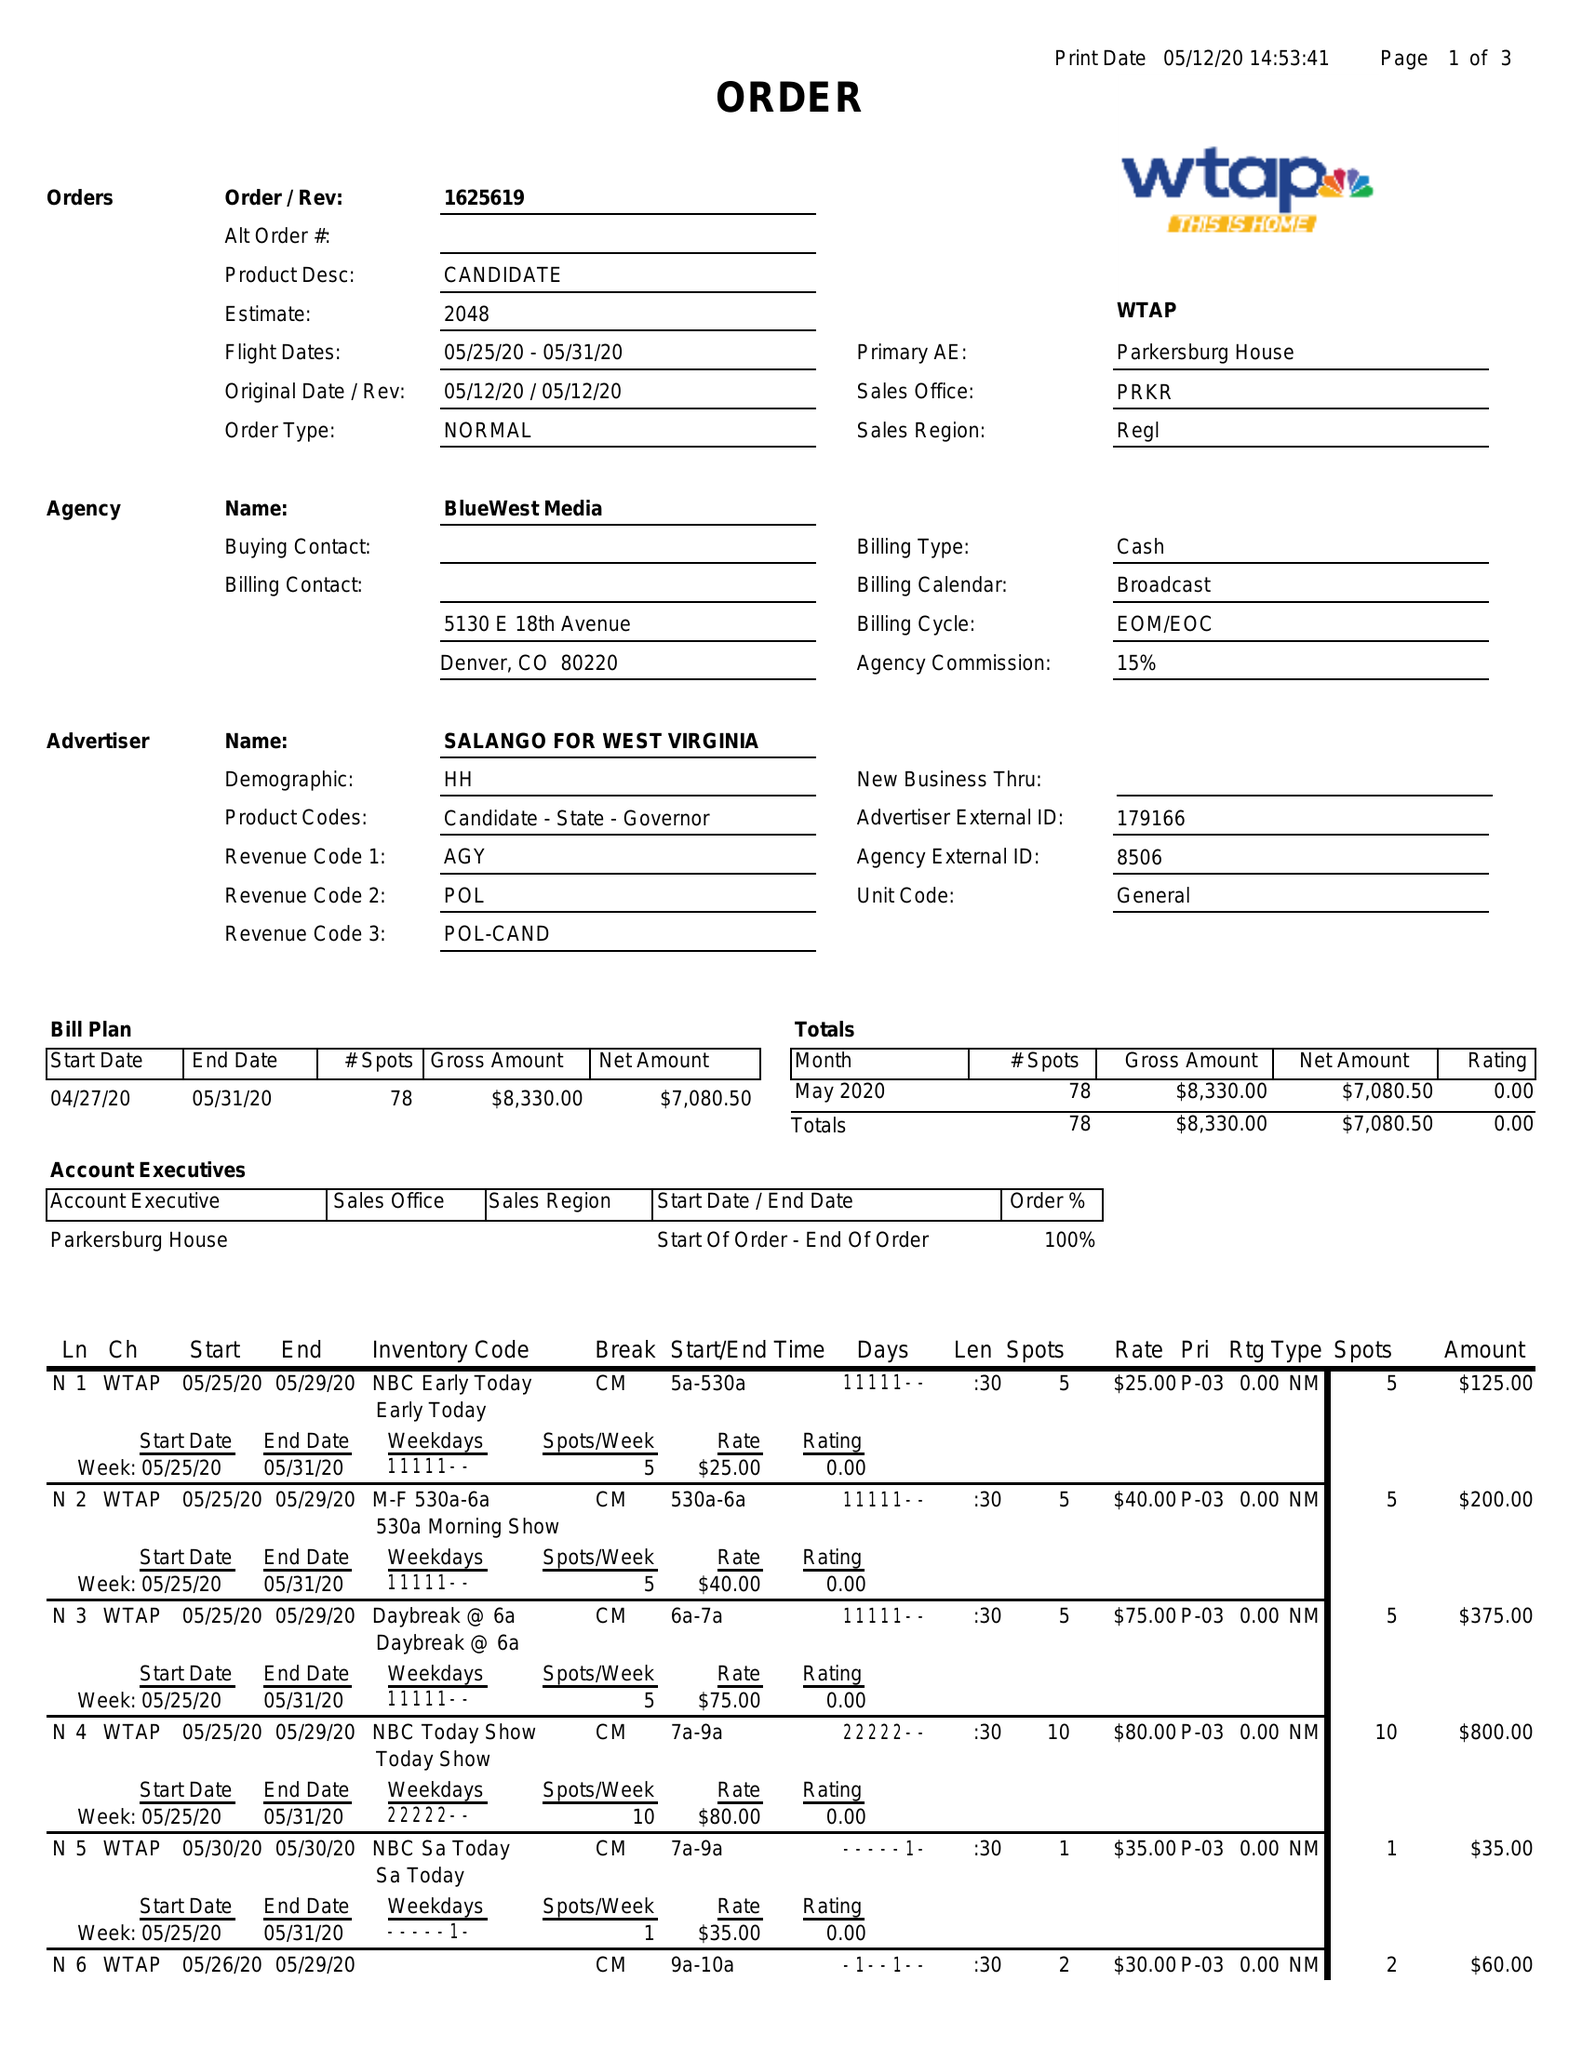What is the value for the gross_amount?
Answer the question using a single word or phrase. 8330.00 